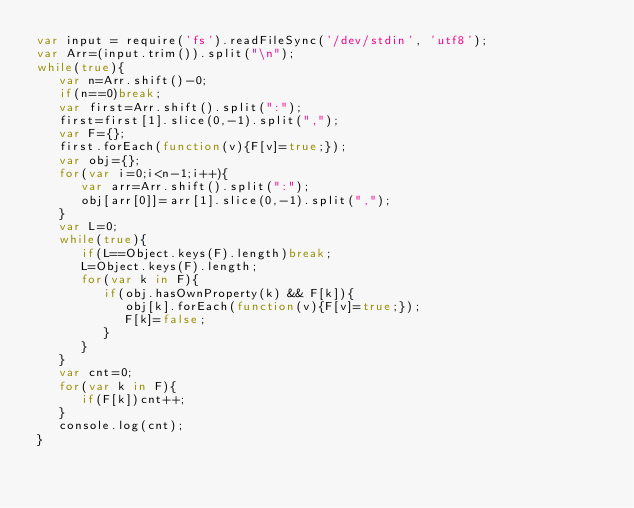Convert code to text. <code><loc_0><loc_0><loc_500><loc_500><_JavaScript_>var input = require('fs').readFileSync('/dev/stdin', 'utf8');
var Arr=(input.trim()).split("\n");
while(true){
   var n=Arr.shift()-0;
   if(n==0)break;
   var first=Arr.shift().split(":");
   first=first[1].slice(0,-1).split(",");
   var F={};
   first.forEach(function(v){F[v]=true;});
   var obj={};
   for(var i=0;i<n-1;i++){
      var arr=Arr.shift().split(":");
      obj[arr[0]]=arr[1].slice(0,-1).split(",");
   }
   var L=0;
   while(true){
      if(L==Object.keys(F).length)break;
      L=Object.keys(F).length;
      for(var k in F){
         if(obj.hasOwnProperty(k) && F[k]){
            obj[k].forEach(function(v){F[v]=true;});
            F[k]=false;
         }
      }
   }
   var cnt=0;
   for(var k in F){
      if(F[k])cnt++;
   }
   console.log(cnt);
}</code> 